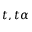<formula> <loc_0><loc_0><loc_500><loc_500>t , t \alpha</formula> 